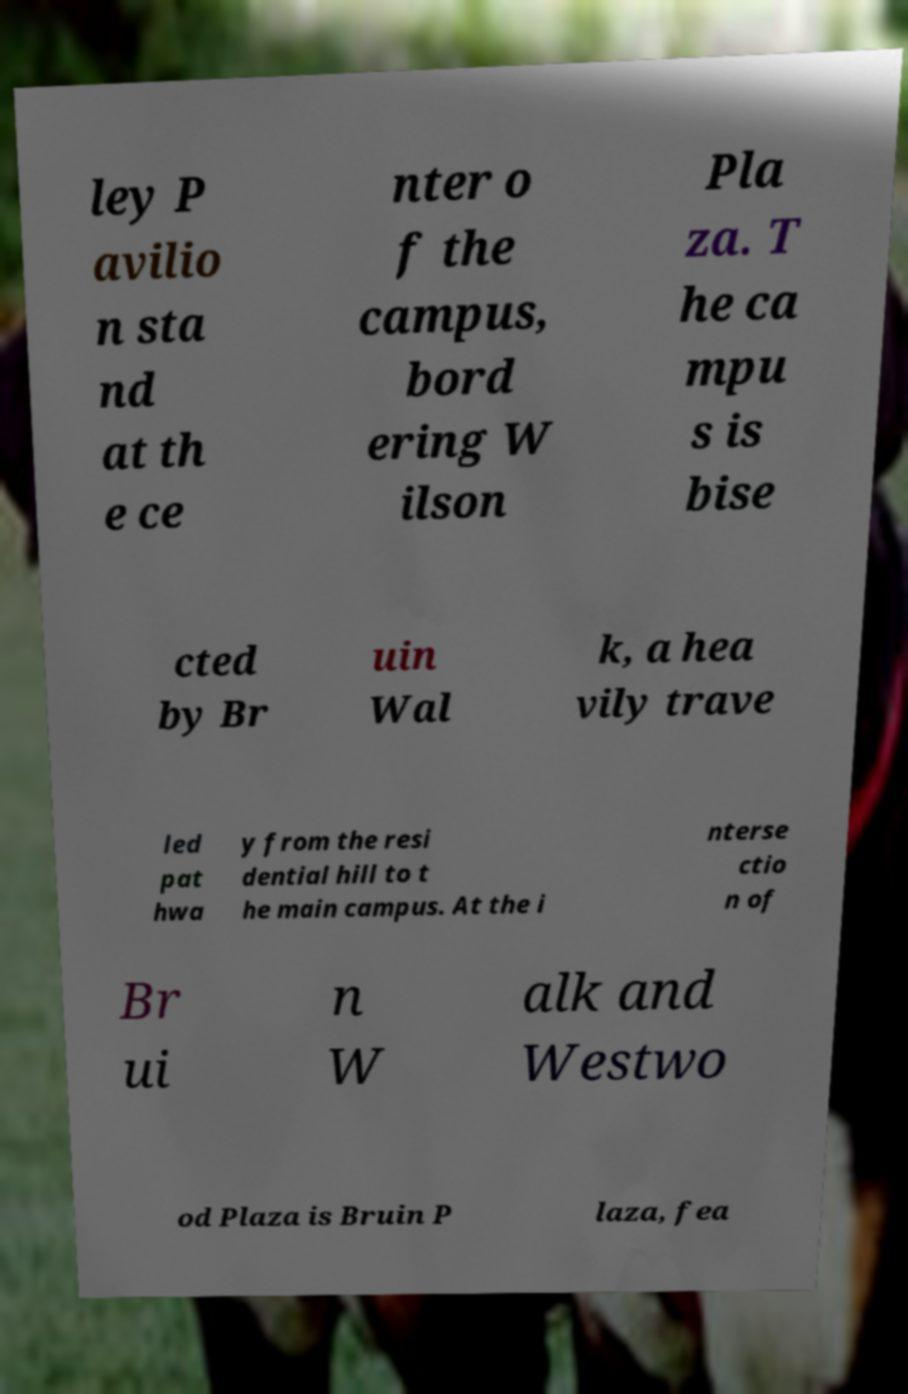There's text embedded in this image that I need extracted. Can you transcribe it verbatim? ley P avilio n sta nd at th e ce nter o f the campus, bord ering W ilson Pla za. T he ca mpu s is bise cted by Br uin Wal k, a hea vily trave led pat hwa y from the resi dential hill to t he main campus. At the i nterse ctio n of Br ui n W alk and Westwo od Plaza is Bruin P laza, fea 